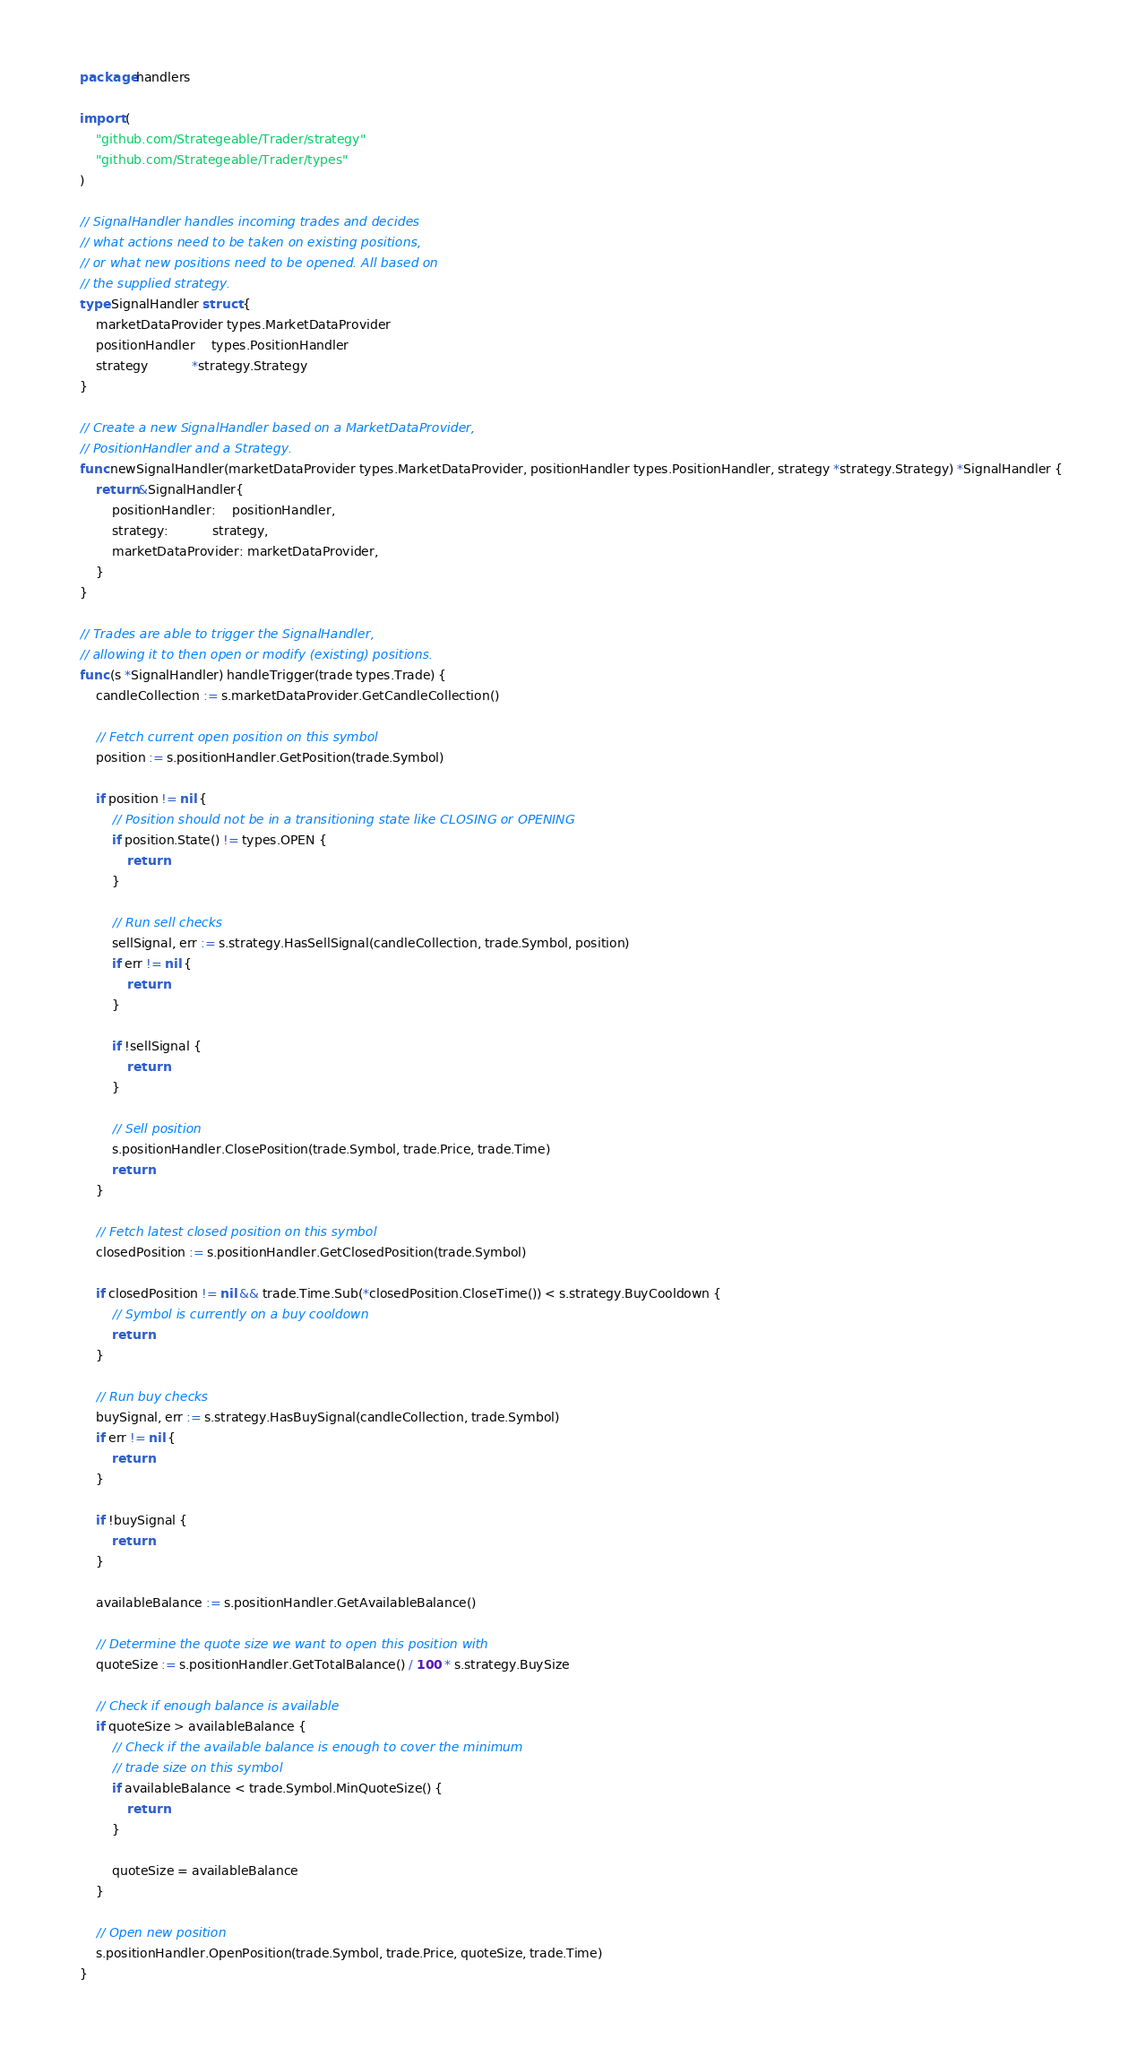Convert code to text. <code><loc_0><loc_0><loc_500><loc_500><_Go_>package handlers

import (
	"github.com/Strategeable/Trader/strategy"
	"github.com/Strategeable/Trader/types"
)

// SignalHandler handles incoming trades and decides
// what actions need to be taken on existing positions,
// or what new positions need to be opened. All based on
// the supplied strategy.
type SignalHandler struct {
	marketDataProvider types.MarketDataProvider
	positionHandler    types.PositionHandler
	strategy           *strategy.Strategy
}

// Create a new SignalHandler based on a MarketDataProvider,
// PositionHandler and a Strategy.
func newSignalHandler(marketDataProvider types.MarketDataProvider, positionHandler types.PositionHandler, strategy *strategy.Strategy) *SignalHandler {
	return &SignalHandler{
		positionHandler:    positionHandler,
		strategy:           strategy,
		marketDataProvider: marketDataProvider,
	}
}

// Trades are able to trigger the SignalHandler,
// allowing it to then open or modify (existing) positions.
func (s *SignalHandler) handleTrigger(trade types.Trade) {
	candleCollection := s.marketDataProvider.GetCandleCollection()

	// Fetch current open position on this symbol
	position := s.positionHandler.GetPosition(trade.Symbol)

	if position != nil {
		// Position should not be in a transitioning state like CLOSING or OPENING
		if position.State() != types.OPEN {
			return
		}

		// Run sell checks
		sellSignal, err := s.strategy.HasSellSignal(candleCollection, trade.Symbol, position)
		if err != nil {
			return
		}

		if !sellSignal {
			return
		}

		// Sell position
		s.positionHandler.ClosePosition(trade.Symbol, trade.Price, trade.Time)
		return
	}

	// Fetch latest closed position on this symbol
	closedPosition := s.positionHandler.GetClosedPosition(trade.Symbol)

	if closedPosition != nil && trade.Time.Sub(*closedPosition.CloseTime()) < s.strategy.BuyCooldown {
		// Symbol is currently on a buy cooldown
		return
	}

	// Run buy checks
	buySignal, err := s.strategy.HasBuySignal(candleCollection, trade.Symbol)
	if err != nil {
		return
	}

	if !buySignal {
		return
	}

	availableBalance := s.positionHandler.GetAvailableBalance()

	// Determine the quote size we want to open this position with
	quoteSize := s.positionHandler.GetTotalBalance() / 100 * s.strategy.BuySize

	// Check if enough balance is available
	if quoteSize > availableBalance {
		// Check if the available balance is enough to cover the minimum
		// trade size on this symbol
		if availableBalance < trade.Symbol.MinQuoteSize() {
			return
		}

		quoteSize = availableBalance
	}

	// Open new position
	s.positionHandler.OpenPosition(trade.Symbol, trade.Price, quoteSize, trade.Time)
}
</code> 